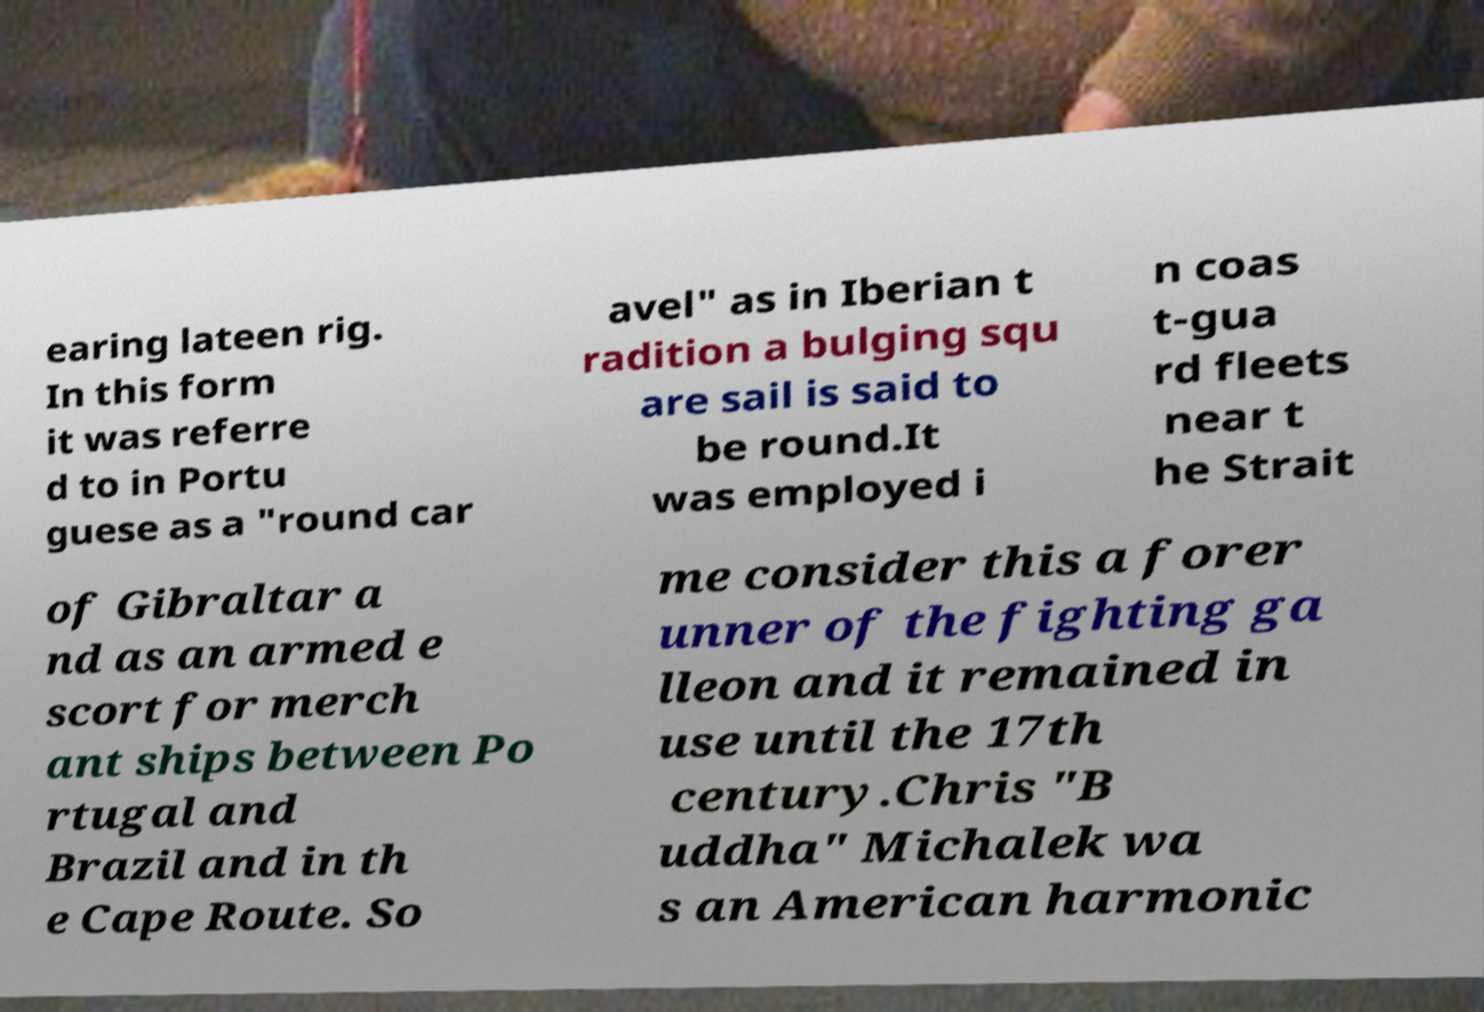Can you read and provide the text displayed in the image?This photo seems to have some interesting text. Can you extract and type it out for me? earing lateen rig. In this form it was referre d to in Portu guese as a "round car avel" as in Iberian t radition a bulging squ are sail is said to be round.It was employed i n coas t-gua rd fleets near t he Strait of Gibraltar a nd as an armed e scort for merch ant ships between Po rtugal and Brazil and in th e Cape Route. So me consider this a forer unner of the fighting ga lleon and it remained in use until the 17th century.Chris "B uddha" Michalek wa s an American harmonic 